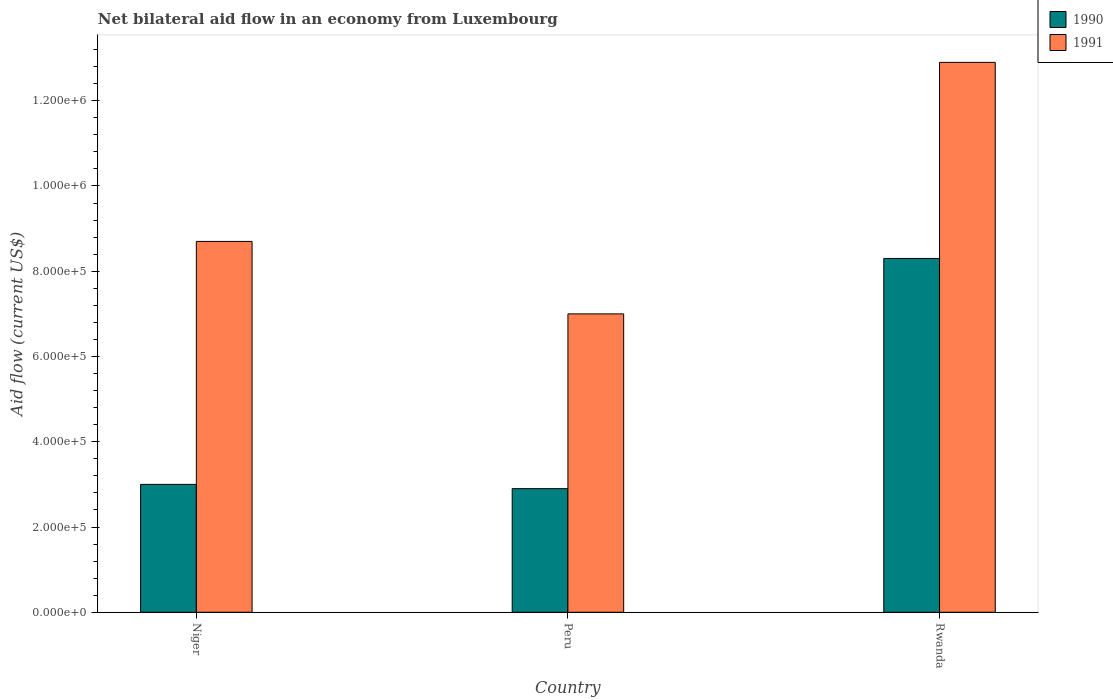How many groups of bars are there?
Offer a terse response. 3. Are the number of bars per tick equal to the number of legend labels?
Give a very brief answer. Yes. How many bars are there on the 3rd tick from the right?
Your response must be concise. 2. What is the label of the 3rd group of bars from the left?
Give a very brief answer. Rwanda. In how many cases, is the number of bars for a given country not equal to the number of legend labels?
Your response must be concise. 0. Across all countries, what is the maximum net bilateral aid flow in 1991?
Your answer should be compact. 1.29e+06. In which country was the net bilateral aid flow in 1991 maximum?
Provide a short and direct response. Rwanda. What is the total net bilateral aid flow in 1991 in the graph?
Keep it short and to the point. 2.86e+06. What is the average net bilateral aid flow in 1991 per country?
Offer a very short reply. 9.53e+05. What is the difference between the net bilateral aid flow of/in 1990 and net bilateral aid flow of/in 1991 in Rwanda?
Provide a succinct answer. -4.60e+05. What is the ratio of the net bilateral aid flow in 1991 in Peru to that in Rwanda?
Ensure brevity in your answer.  0.54. Is the difference between the net bilateral aid flow in 1990 in Niger and Rwanda greater than the difference between the net bilateral aid flow in 1991 in Niger and Rwanda?
Your answer should be compact. No. What is the difference between the highest and the lowest net bilateral aid flow in 1990?
Offer a terse response. 5.40e+05. Is the sum of the net bilateral aid flow in 1991 in Peru and Rwanda greater than the maximum net bilateral aid flow in 1990 across all countries?
Ensure brevity in your answer.  Yes. What does the 1st bar from the right in Niger represents?
Offer a terse response. 1991. How many bars are there?
Offer a terse response. 6. What is the difference between two consecutive major ticks on the Y-axis?
Keep it short and to the point. 2.00e+05. Does the graph contain grids?
Give a very brief answer. No. Where does the legend appear in the graph?
Offer a terse response. Top right. How many legend labels are there?
Ensure brevity in your answer.  2. What is the title of the graph?
Offer a very short reply. Net bilateral aid flow in an economy from Luxembourg. What is the Aid flow (current US$) of 1991 in Niger?
Your answer should be compact. 8.70e+05. What is the Aid flow (current US$) of 1990 in Rwanda?
Keep it short and to the point. 8.30e+05. What is the Aid flow (current US$) in 1991 in Rwanda?
Offer a terse response. 1.29e+06. Across all countries, what is the maximum Aid flow (current US$) of 1990?
Ensure brevity in your answer.  8.30e+05. Across all countries, what is the maximum Aid flow (current US$) in 1991?
Provide a succinct answer. 1.29e+06. Across all countries, what is the minimum Aid flow (current US$) in 1990?
Provide a succinct answer. 2.90e+05. What is the total Aid flow (current US$) of 1990 in the graph?
Keep it short and to the point. 1.42e+06. What is the total Aid flow (current US$) in 1991 in the graph?
Ensure brevity in your answer.  2.86e+06. What is the difference between the Aid flow (current US$) in 1990 in Niger and that in Rwanda?
Make the answer very short. -5.30e+05. What is the difference between the Aid flow (current US$) in 1991 in Niger and that in Rwanda?
Provide a short and direct response. -4.20e+05. What is the difference between the Aid flow (current US$) of 1990 in Peru and that in Rwanda?
Your response must be concise. -5.40e+05. What is the difference between the Aid flow (current US$) of 1991 in Peru and that in Rwanda?
Make the answer very short. -5.90e+05. What is the difference between the Aid flow (current US$) in 1990 in Niger and the Aid flow (current US$) in 1991 in Peru?
Provide a succinct answer. -4.00e+05. What is the difference between the Aid flow (current US$) in 1990 in Niger and the Aid flow (current US$) in 1991 in Rwanda?
Your response must be concise. -9.90e+05. What is the difference between the Aid flow (current US$) of 1990 in Peru and the Aid flow (current US$) of 1991 in Rwanda?
Give a very brief answer. -1.00e+06. What is the average Aid flow (current US$) of 1990 per country?
Give a very brief answer. 4.73e+05. What is the average Aid flow (current US$) in 1991 per country?
Offer a very short reply. 9.53e+05. What is the difference between the Aid flow (current US$) in 1990 and Aid flow (current US$) in 1991 in Niger?
Ensure brevity in your answer.  -5.70e+05. What is the difference between the Aid flow (current US$) of 1990 and Aid flow (current US$) of 1991 in Peru?
Provide a succinct answer. -4.10e+05. What is the difference between the Aid flow (current US$) in 1990 and Aid flow (current US$) in 1991 in Rwanda?
Offer a terse response. -4.60e+05. What is the ratio of the Aid flow (current US$) in 1990 in Niger to that in Peru?
Your answer should be very brief. 1.03. What is the ratio of the Aid flow (current US$) in 1991 in Niger to that in Peru?
Provide a short and direct response. 1.24. What is the ratio of the Aid flow (current US$) in 1990 in Niger to that in Rwanda?
Your response must be concise. 0.36. What is the ratio of the Aid flow (current US$) in 1991 in Niger to that in Rwanda?
Make the answer very short. 0.67. What is the ratio of the Aid flow (current US$) in 1990 in Peru to that in Rwanda?
Ensure brevity in your answer.  0.35. What is the ratio of the Aid flow (current US$) in 1991 in Peru to that in Rwanda?
Provide a short and direct response. 0.54. What is the difference between the highest and the second highest Aid flow (current US$) of 1990?
Your answer should be very brief. 5.30e+05. What is the difference between the highest and the second highest Aid flow (current US$) in 1991?
Your response must be concise. 4.20e+05. What is the difference between the highest and the lowest Aid flow (current US$) in 1990?
Ensure brevity in your answer.  5.40e+05. What is the difference between the highest and the lowest Aid flow (current US$) in 1991?
Provide a succinct answer. 5.90e+05. 